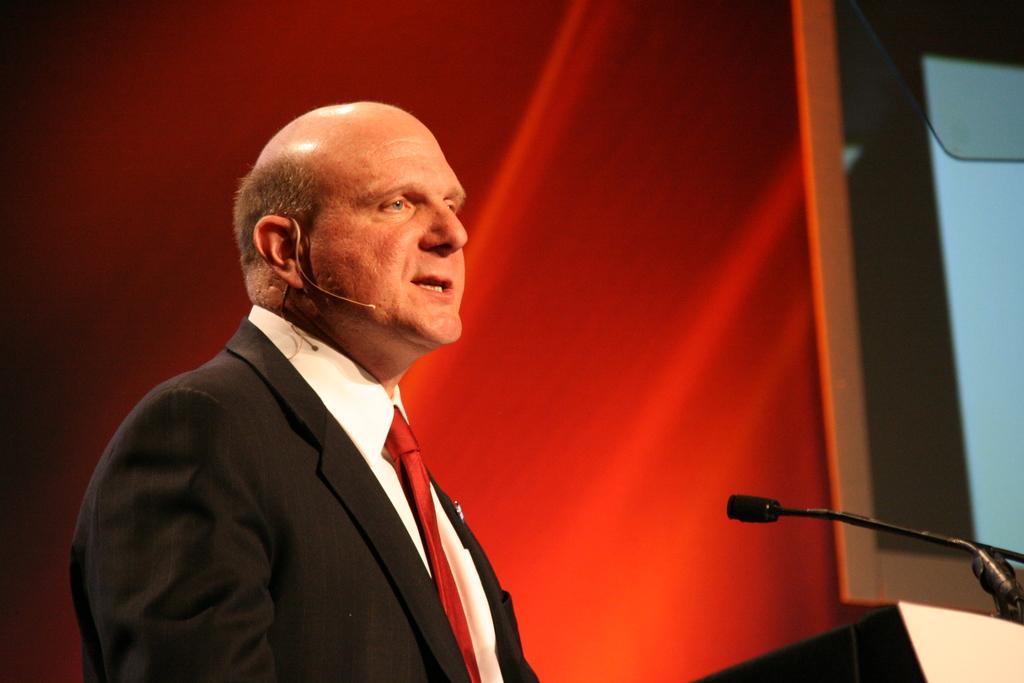Describe this image in one or two sentences. In this image, we can see a person. We can also see an object on the bottom right corner. We can see a microphone and the background. We can also see a screen on the right. 